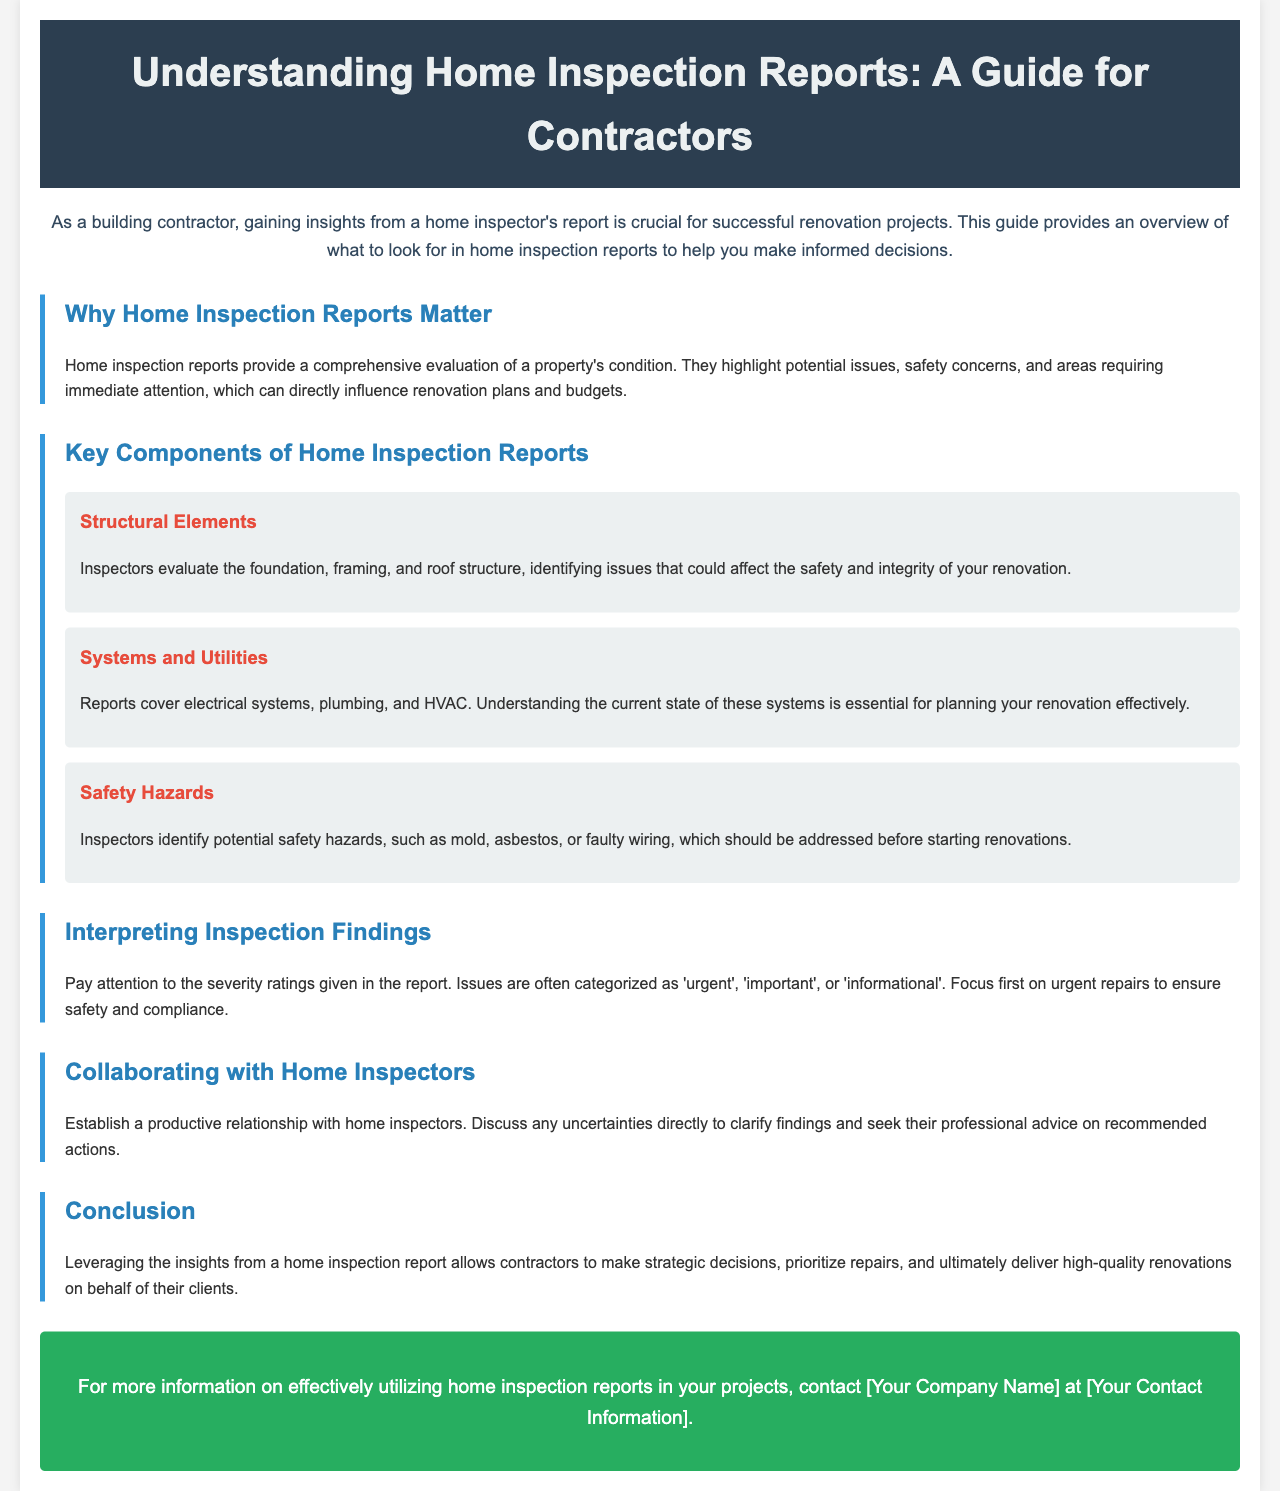what is the title of the brochure? The title of the brochure is prominently displayed at the top of the document.
Answer: Understanding Home Inspection Reports: A Guide for Contractors what is one reason why home inspection reports matter? The document states that home inspection reports highlight potential issues and safety concerns.
Answer: They highlight potential issues, safety concerns, and areas requiring immediate attention name a key component evaluated in home inspection reports. The brochure lists several key components, one of which falls under structural evaluation.
Answer: Structural Elements how are issues categorized in inspection findings? The document explains that issues are categorized based on severity ratings.
Answer: Urgent, important, or informational who should contractors establish a relationship with? A section of the brochure emphasizes collaboration with a specific professional group.
Answer: Home Inspectors what should be focused on first in inspection findings? The document suggests prioritizing repairs based on the severity ratings provided.
Answer: Urgent repairs what color is used for section headings in the brochure? The colors used for section headings can help identify them at a glance.
Answer: Blue how can contractors contact the company for more information? The brochure provides a specific call to action at the bottom for further inquiries.
Answer: Contact [Your Company Name] at [Your Contact Information] 